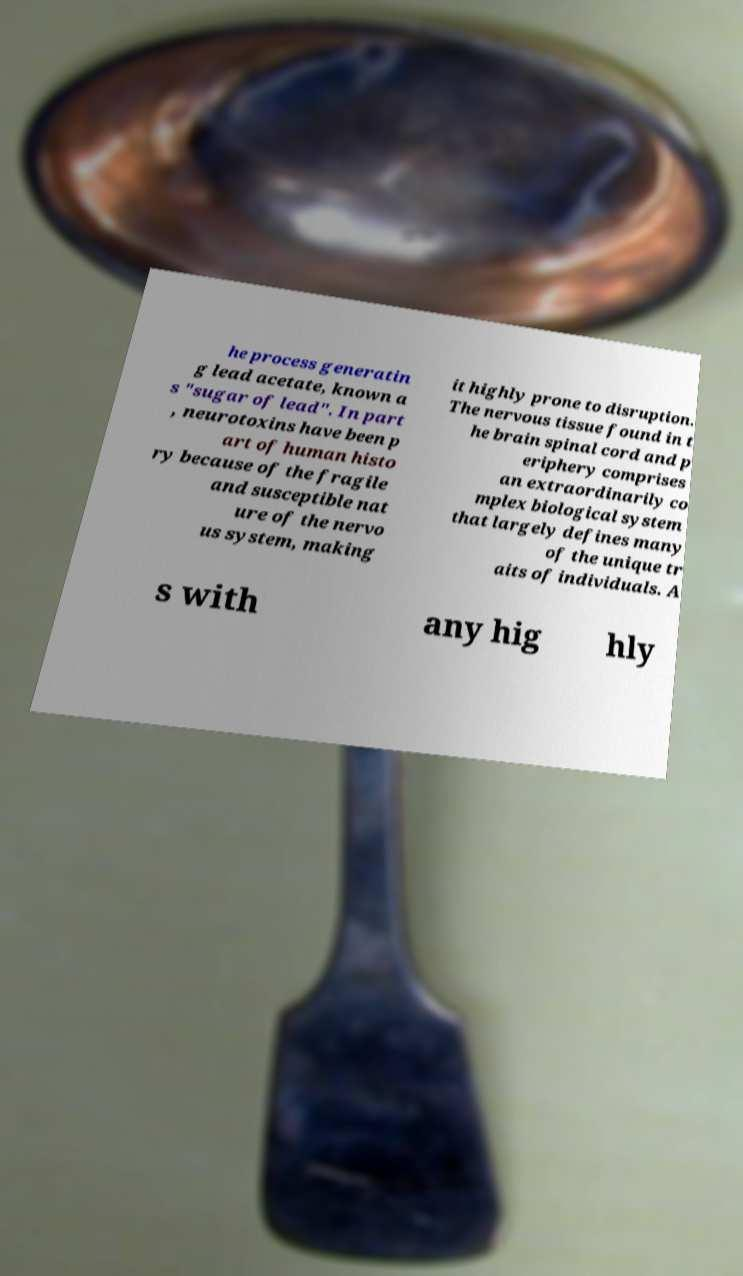For documentation purposes, I need the text within this image transcribed. Could you provide that? he process generatin g lead acetate, known a s "sugar of lead". In part , neurotoxins have been p art of human histo ry because of the fragile and susceptible nat ure of the nervo us system, making it highly prone to disruption. The nervous tissue found in t he brain spinal cord and p eriphery comprises an extraordinarily co mplex biological system that largely defines many of the unique tr aits of individuals. A s with any hig hly 